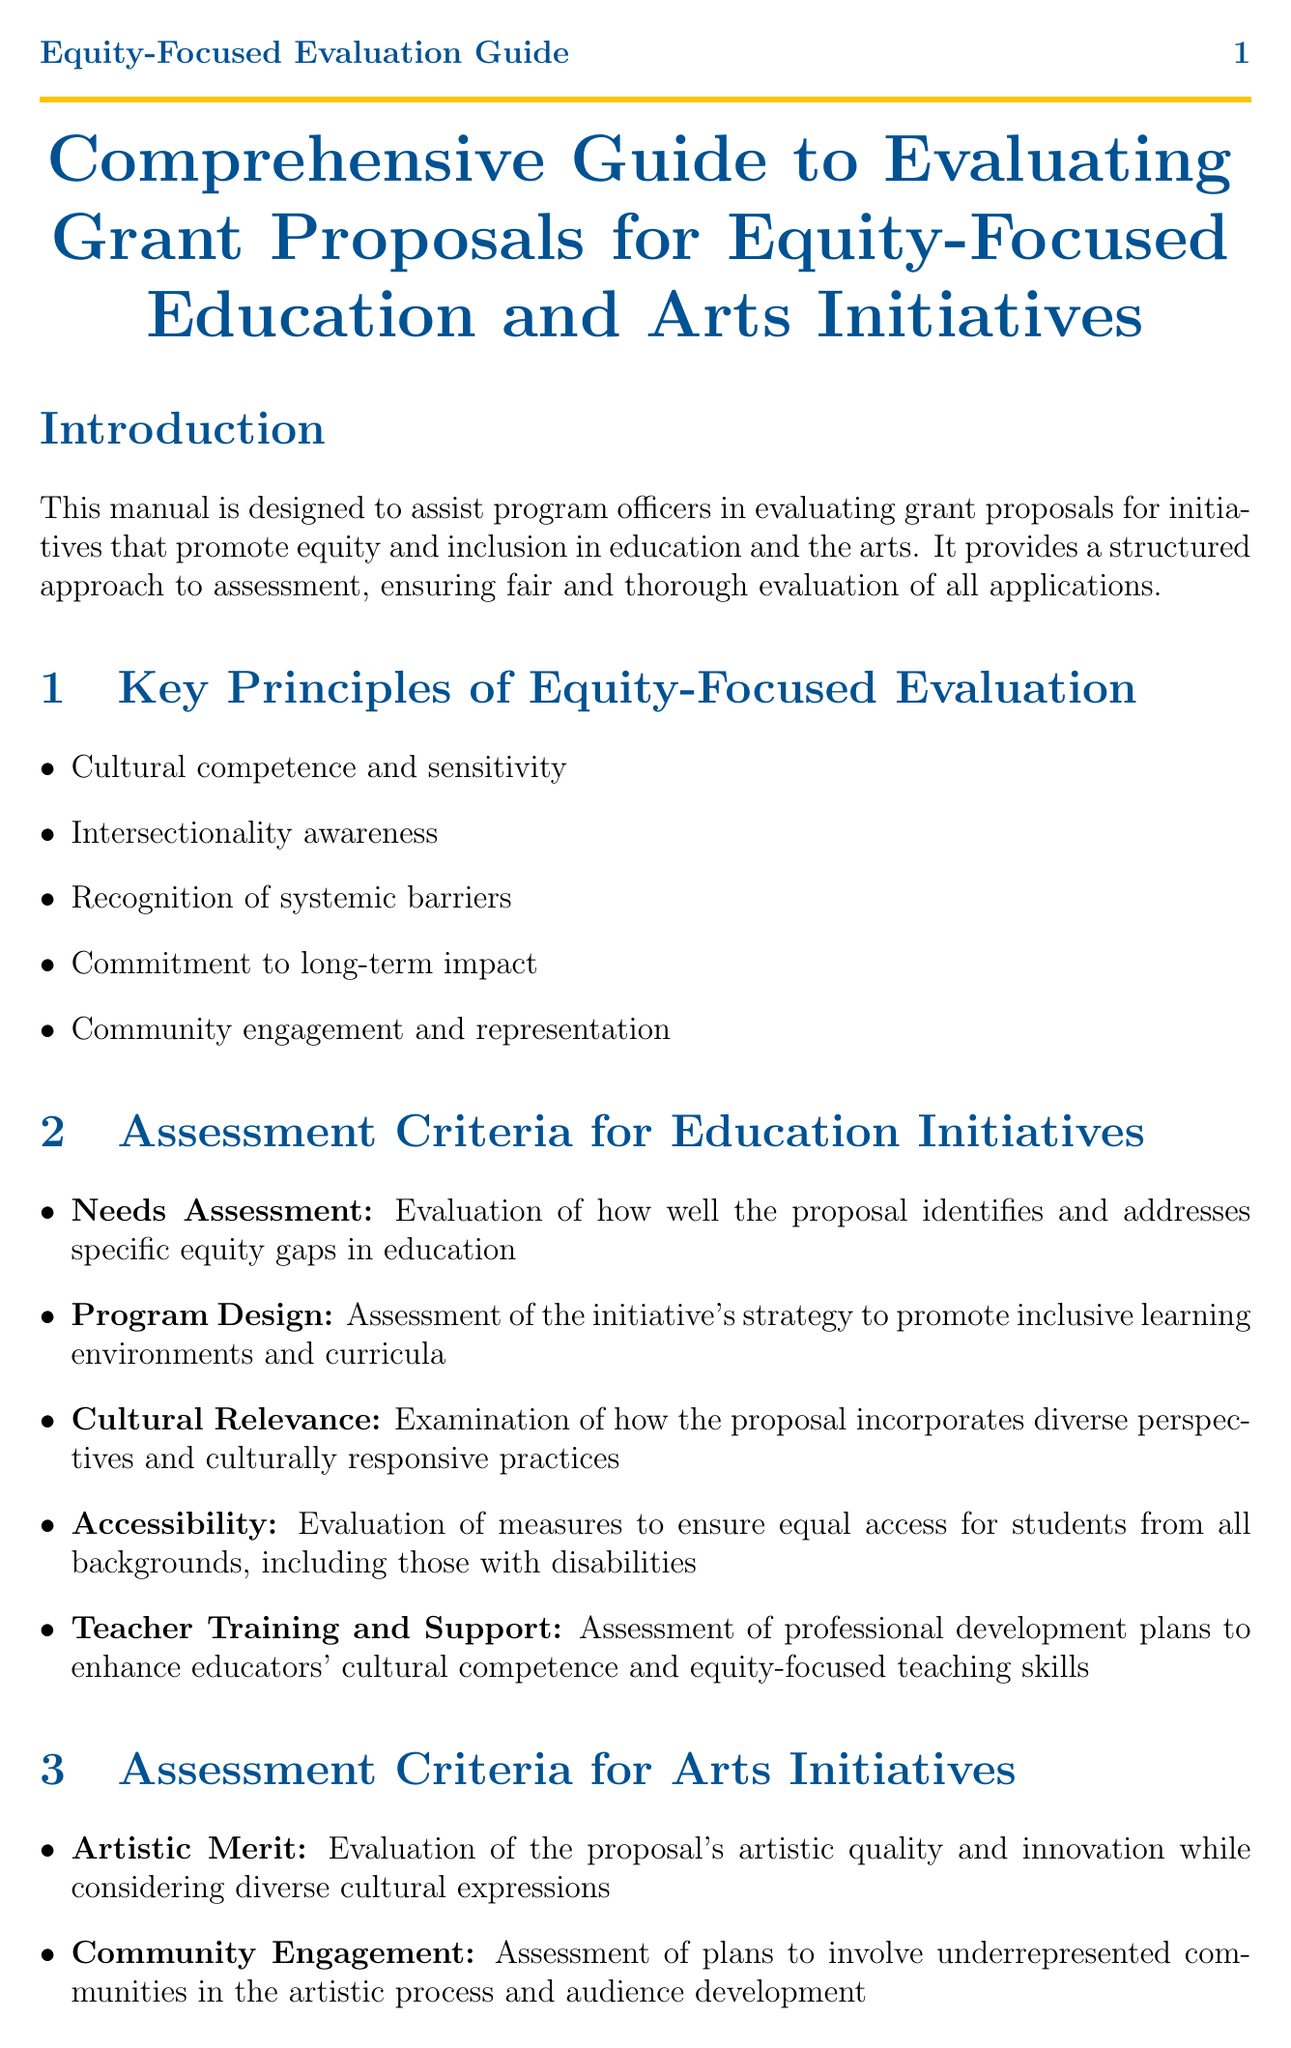What is the title of the manual? The title of the manual is provided at the beginning, stating its focus on evaluating grant proposals for equity-focused education and arts initiatives.
Answer: Comprehensive Guide to Evaluating Grant Proposals for Equity-Focused Education and Arts Initiatives What percentage weight is assigned to "Alignment with Equity Goals"? The percentage weight is listed in the scoring rubric section, indicating its importance in the evaluation process.
Answer: 25% Name one of the key principles of equity-focused evaluation. The key principles are listed in the relevant section and highlight essential considerations for fair evaluation.
Answer: Cultural competence and sensitivity What is a common pitfall to avoid in proposals? Common pitfalls are enumerated to guide program officers in identifying shortcomings in grant proposals.
Answer: Tokenism in representation Which case study focuses on a music initiative? The case studies section details two initiatives, asking specifically about a project related to music.
Answer: Harmony Arts Project 